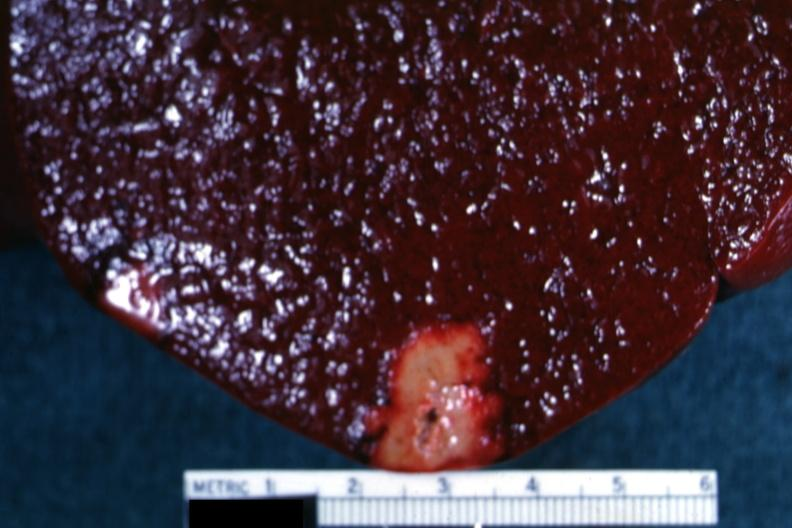what does this image show?
Answer the question using a single word or phrase. Yellow infarct with band of reactive hyperemia 